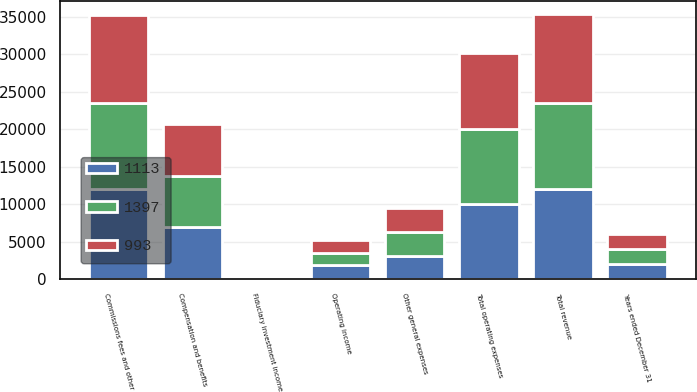Convert chart to OTSL. <chart><loc_0><loc_0><loc_500><loc_500><stacked_bar_chart><ecel><fcel>Years ended December 31<fcel>Commissions fees and other<fcel>Fiduciary investment income<fcel>Total revenue<fcel>Compensation and benefits<fcel>Other general expenses<fcel>Total operating expenses<fcel>Operating income<nl><fcel>1113<fcel>2014<fcel>12019<fcel>26<fcel>12045<fcel>7014<fcel>3065<fcel>10079<fcel>1966<nl><fcel>993<fcel>2013<fcel>11787<fcel>28<fcel>11815<fcel>6945<fcel>3199<fcel>10144<fcel>1671<nl><fcel>1397<fcel>2012<fcel>11476<fcel>38<fcel>11514<fcel>6709<fcel>3209<fcel>9918<fcel>1596<nl></chart> 